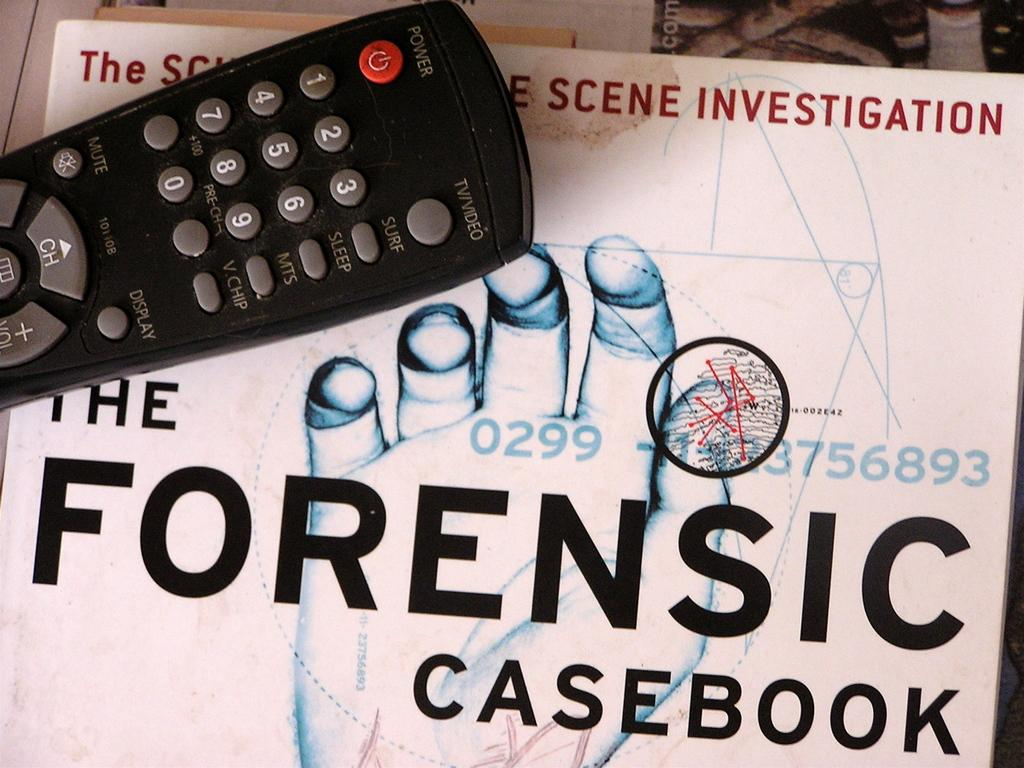<image>
Describe the image concisely. A remote control is resting on a book about crime scene investigation. 